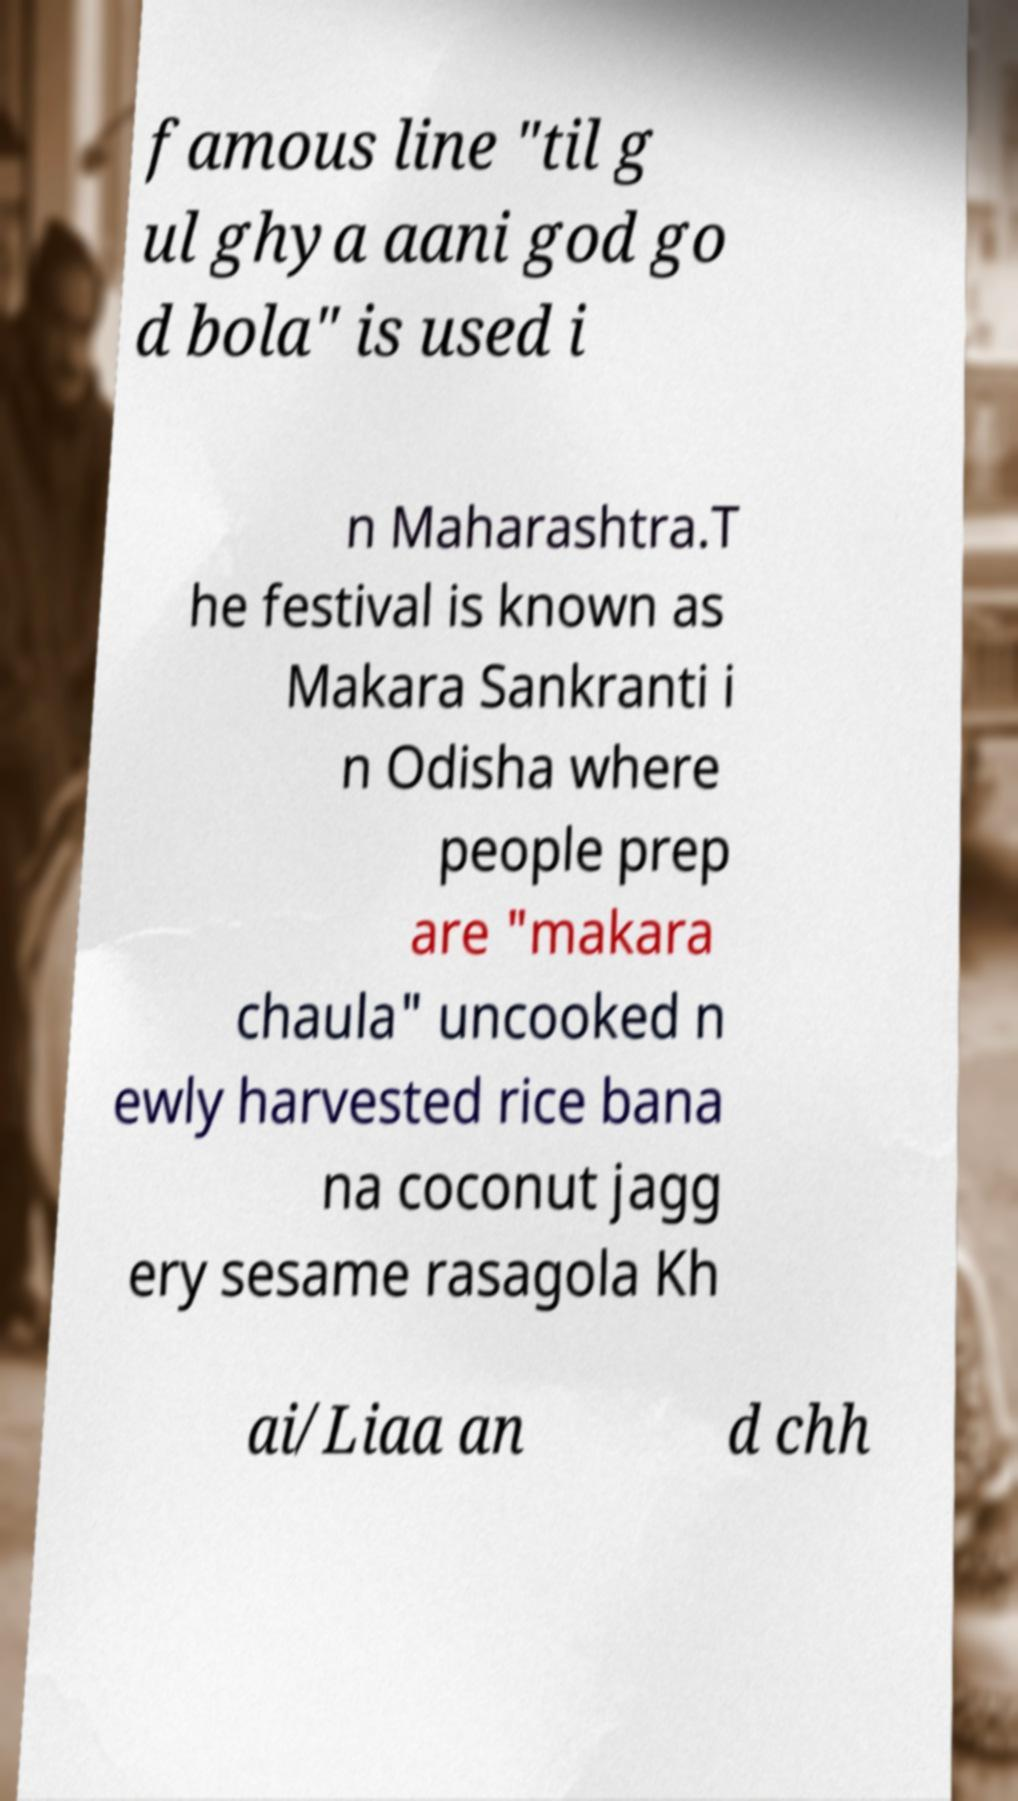Could you extract and type out the text from this image? famous line "til g ul ghya aani god go d bola" is used i n Maharashtra.T he festival is known as Makara Sankranti i n Odisha where people prep are "makara chaula" uncooked n ewly harvested rice bana na coconut jagg ery sesame rasagola Kh ai/Liaa an d chh 